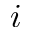<formula> <loc_0><loc_0><loc_500><loc_500>i</formula> 